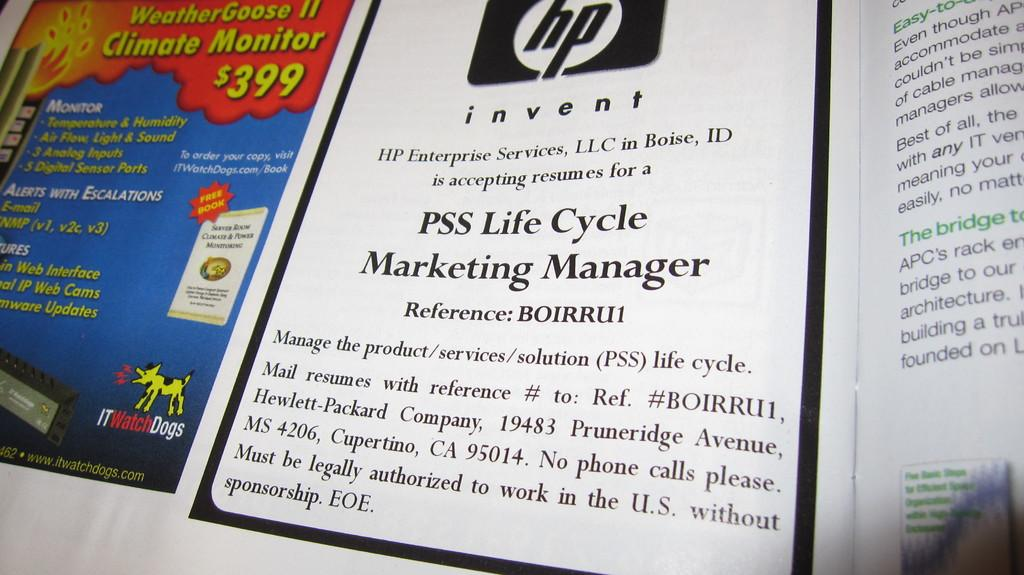<image>
Summarize the visual content of the image. An advertisement announces that HP Enterprise Services is accepting resumes for PSS Life Cycle Marketing Manager. 